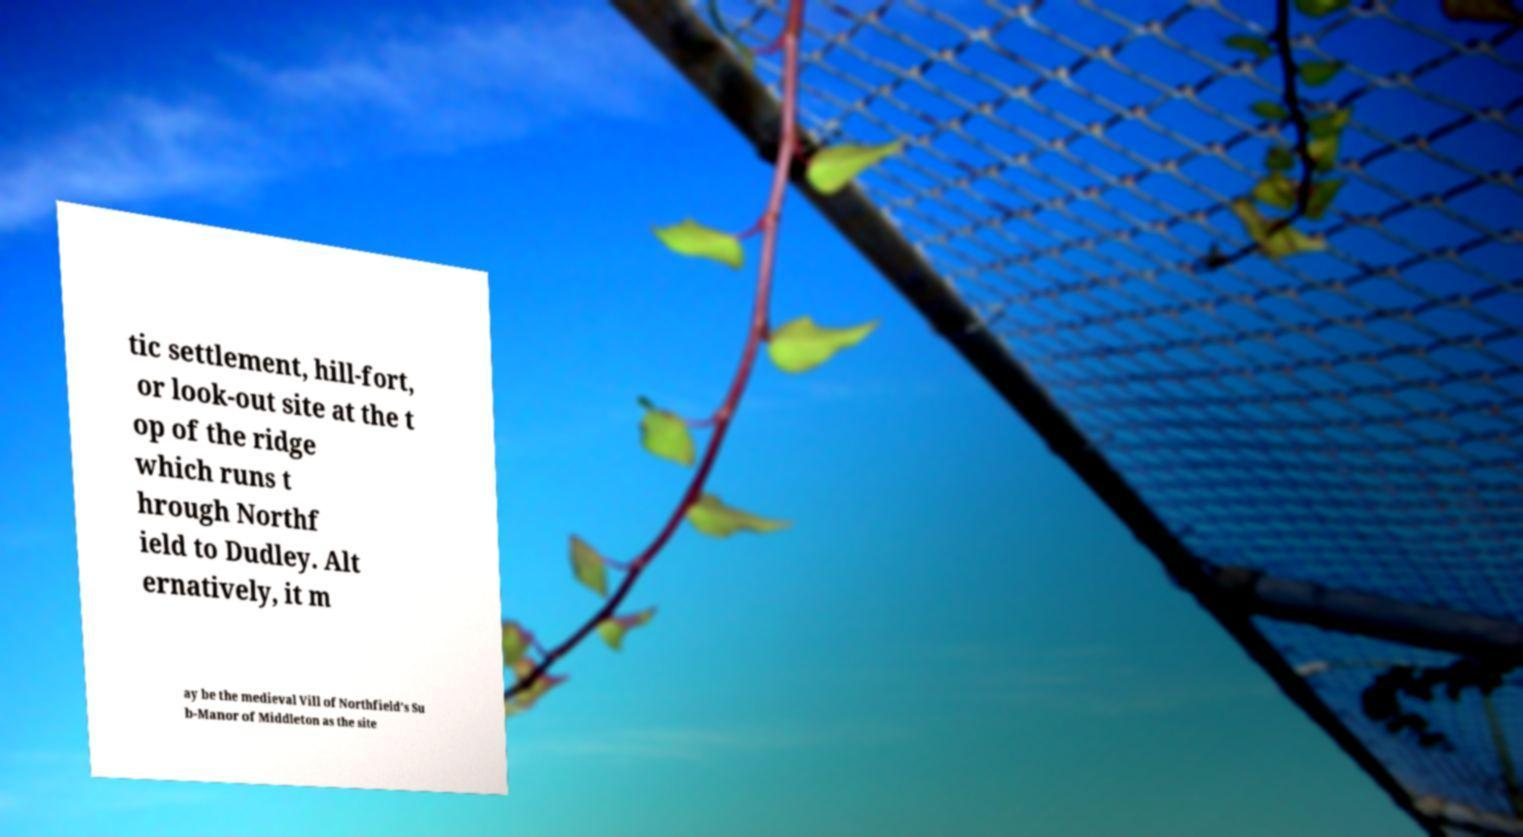Could you extract and type out the text from this image? tic settlement, hill-fort, or look-out site at the t op of the ridge which runs t hrough Northf ield to Dudley. Alt ernatively, it m ay be the medieval Vill of Northfield’s Su b-Manor of Middleton as the site 